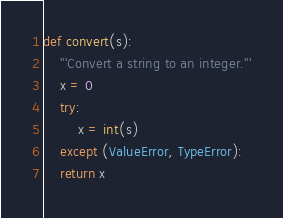<code> <loc_0><loc_0><loc_500><loc_500><_Python_>def convert(s):
    '''Convert a string to an integer.'''
    x = 0
    try:
        x = int(s)
    except (ValueError, TypeError):
    return x
</code> 